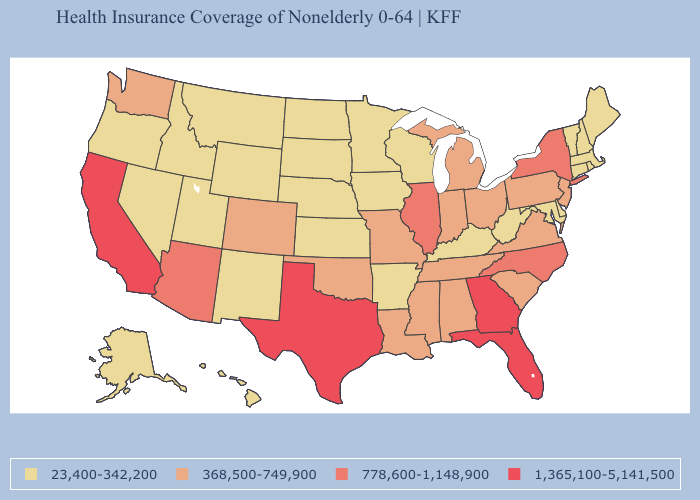What is the lowest value in the USA?
Give a very brief answer. 23,400-342,200. Name the states that have a value in the range 1,365,100-5,141,500?
Give a very brief answer. California, Florida, Georgia, Texas. What is the value of Connecticut?
Short answer required. 23,400-342,200. Which states hav the highest value in the Northeast?
Keep it brief. New York. Among the states that border South Carolina , which have the lowest value?
Short answer required. North Carolina. What is the value of Maine?
Concise answer only. 23,400-342,200. Does the map have missing data?
Short answer required. No. Among the states that border Nevada , does Idaho have the highest value?
Write a very short answer. No. Name the states that have a value in the range 1,365,100-5,141,500?
Concise answer only. California, Florida, Georgia, Texas. Does Arizona have the highest value in the USA?
Write a very short answer. No. What is the value of Nebraska?
Concise answer only. 23,400-342,200. Name the states that have a value in the range 23,400-342,200?
Be succinct. Alaska, Arkansas, Connecticut, Delaware, Hawaii, Idaho, Iowa, Kansas, Kentucky, Maine, Maryland, Massachusetts, Minnesota, Montana, Nebraska, Nevada, New Hampshire, New Mexico, North Dakota, Oregon, Rhode Island, South Dakota, Utah, Vermont, West Virginia, Wisconsin, Wyoming. What is the value of Washington?
Concise answer only. 368,500-749,900. Does the map have missing data?
Keep it brief. No. 